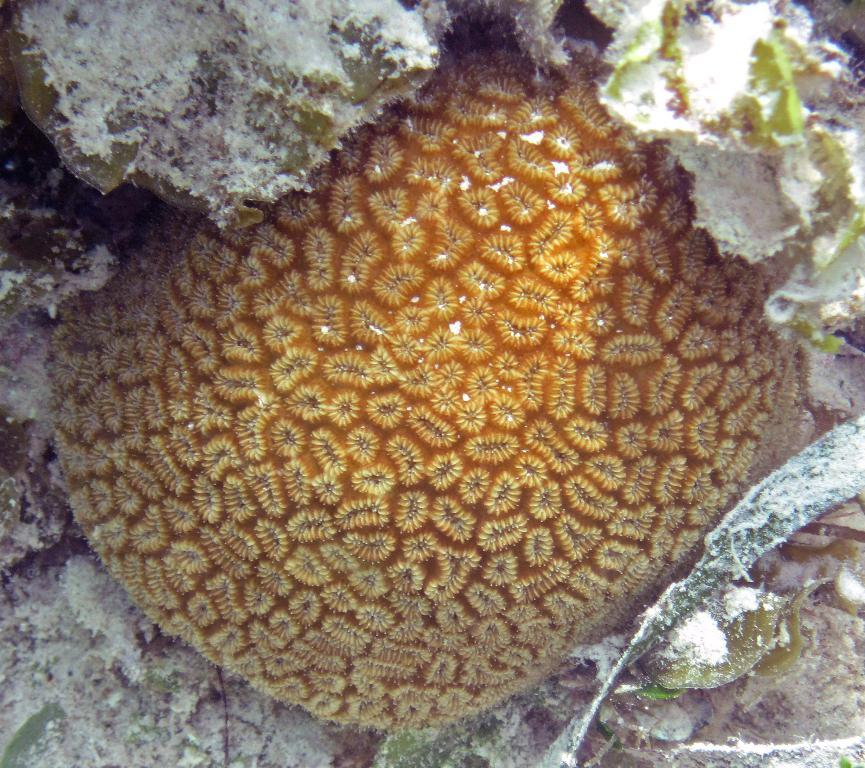Can you describe the main subject or object in the image? Unfortunately, there is not enough information provided to determine the main subject or object in the image. What type of seat is depicted in the image? There is not enough information provided to determine if a seat is present in the image. What type of drink is being consumed in the image? There is not enough information provided to determine if a drink is present in the image. 